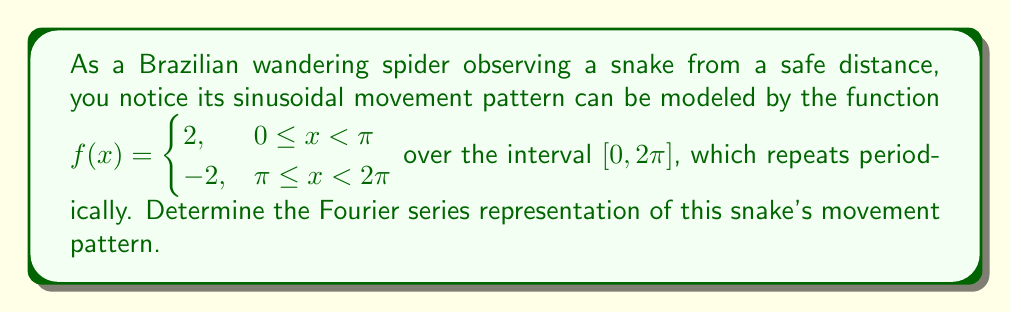Can you solve this math problem? To find the Fourier series representation, we need to calculate the Fourier coefficients $a_0$, $a_n$, and $b_n$.

1. Calculate $a_0$:
   $$a_0 = \frac{1}{\pi} \int_0^{2\pi} f(x) dx = \frac{1}{\pi} \left(\int_0^{\pi} 2 dx + \int_{\pi}^{2\pi} -2 dx\right) = \frac{1}{\pi} (2\pi - 2\pi) = 0$$

2. Calculate $a_n$:
   $$a_n = \frac{1}{\pi} \int_0^{2\pi} f(x) \cos(nx) dx = \frac{1}{\pi} \left(\int_0^{\pi} 2\cos(nx) dx - \int_{\pi}^{2\pi} 2\cos(nx) dx\right)$$
   $$= \frac{2}{\pi n} [\sin(nx)]_0^{\pi} - \frac{2}{\pi n} [\sin(nx)]_{\pi}^{2\pi} = \frac{2}{\pi n} (0 - 0) - \frac{2}{\pi n} (0 - 0) = 0$$

3. Calculate $b_n$:
   $$b_n = \frac{1}{\pi} \int_0^{2\pi} f(x) \sin(nx) dx = \frac{1}{\pi} \left(\int_0^{\pi} 2\sin(nx) dx - \int_{\pi}^{2\pi} 2\sin(nx) dx\right)$$
   $$= -\frac{2}{\pi n} [\cos(nx)]_0^{\pi} + \frac{2}{\pi n} [\cos(nx)]_{\pi}^{2\pi} = -\frac{2}{\pi n} (-1 - 1) + \frac{2}{\pi n} (1 - (-1)) = \frac{8}{\pi n}$$
   Note that this is only valid for odd $n$. For even $n$, $b_n = 0$.

Therefore, the Fourier series representation is:
$$f(x) = \frac{4}{\pi} \left(\sin(x) + \frac{1}{3}\sin(3x) + \frac{1}{5}\sin(5x) + \cdots\right)$$
Answer: $$f(x) = \frac{4}{\pi} \sum_{k=0}^{\infty} \frac{\sin((2k+1)x)}{2k+1}$$ 